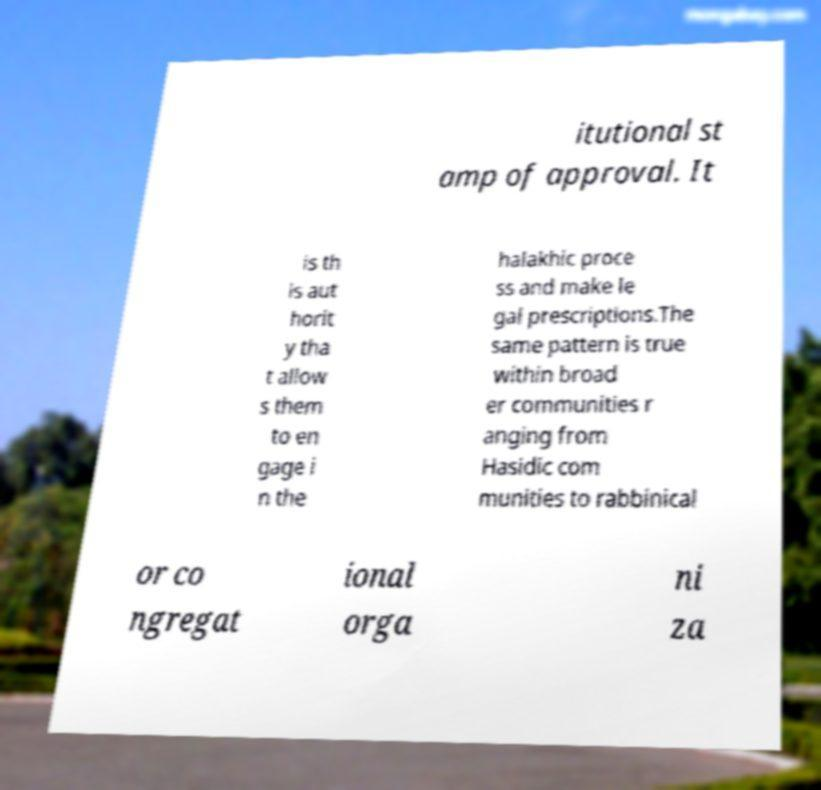Could you extract and type out the text from this image? itutional st amp of approval. It is th is aut horit y tha t allow s them to en gage i n the halakhic proce ss and make le gal prescriptions.The same pattern is true within broad er communities r anging from Hasidic com munities to rabbinical or co ngregat ional orga ni za 